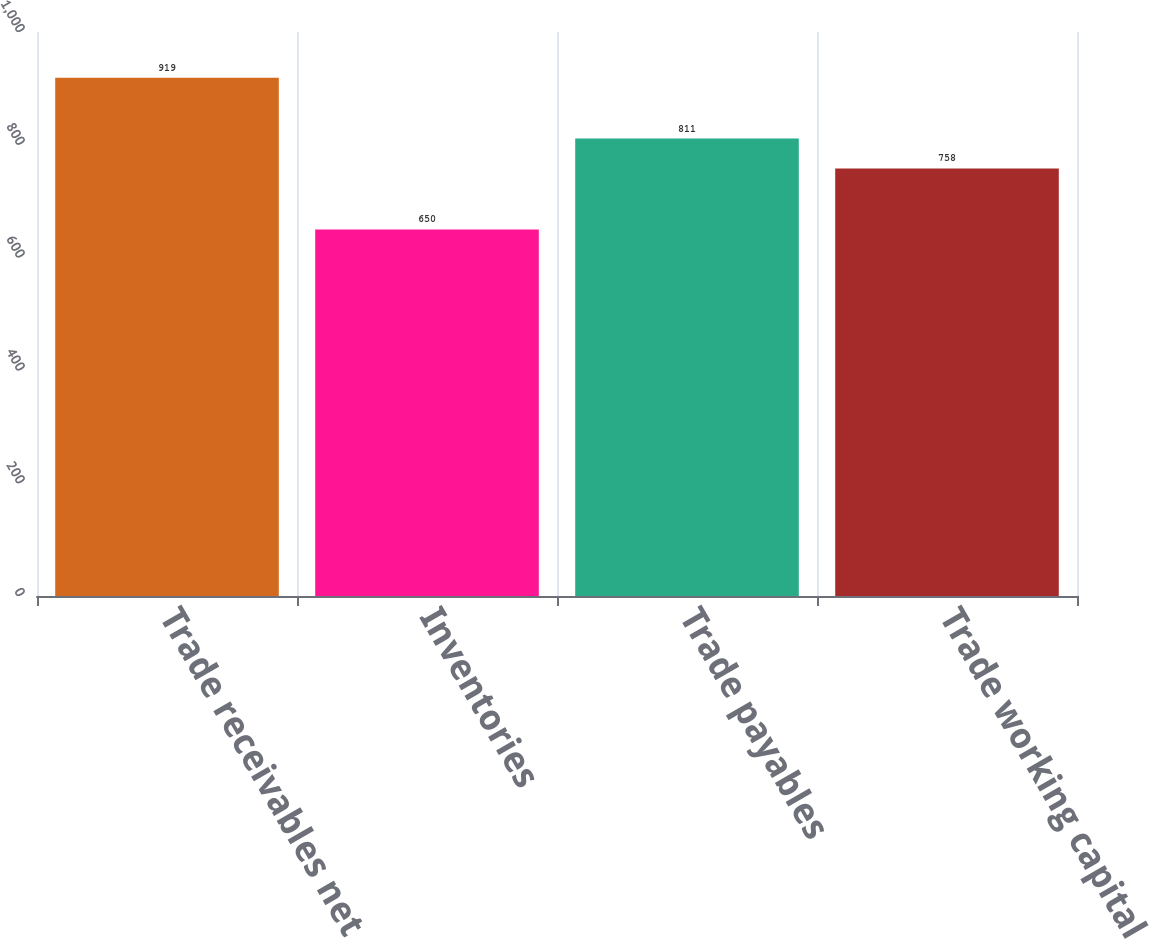Convert chart to OTSL. <chart><loc_0><loc_0><loc_500><loc_500><bar_chart><fcel>Trade receivables net<fcel>Inventories<fcel>Trade payables<fcel>Trade working capital<nl><fcel>919<fcel>650<fcel>811<fcel>758<nl></chart> 